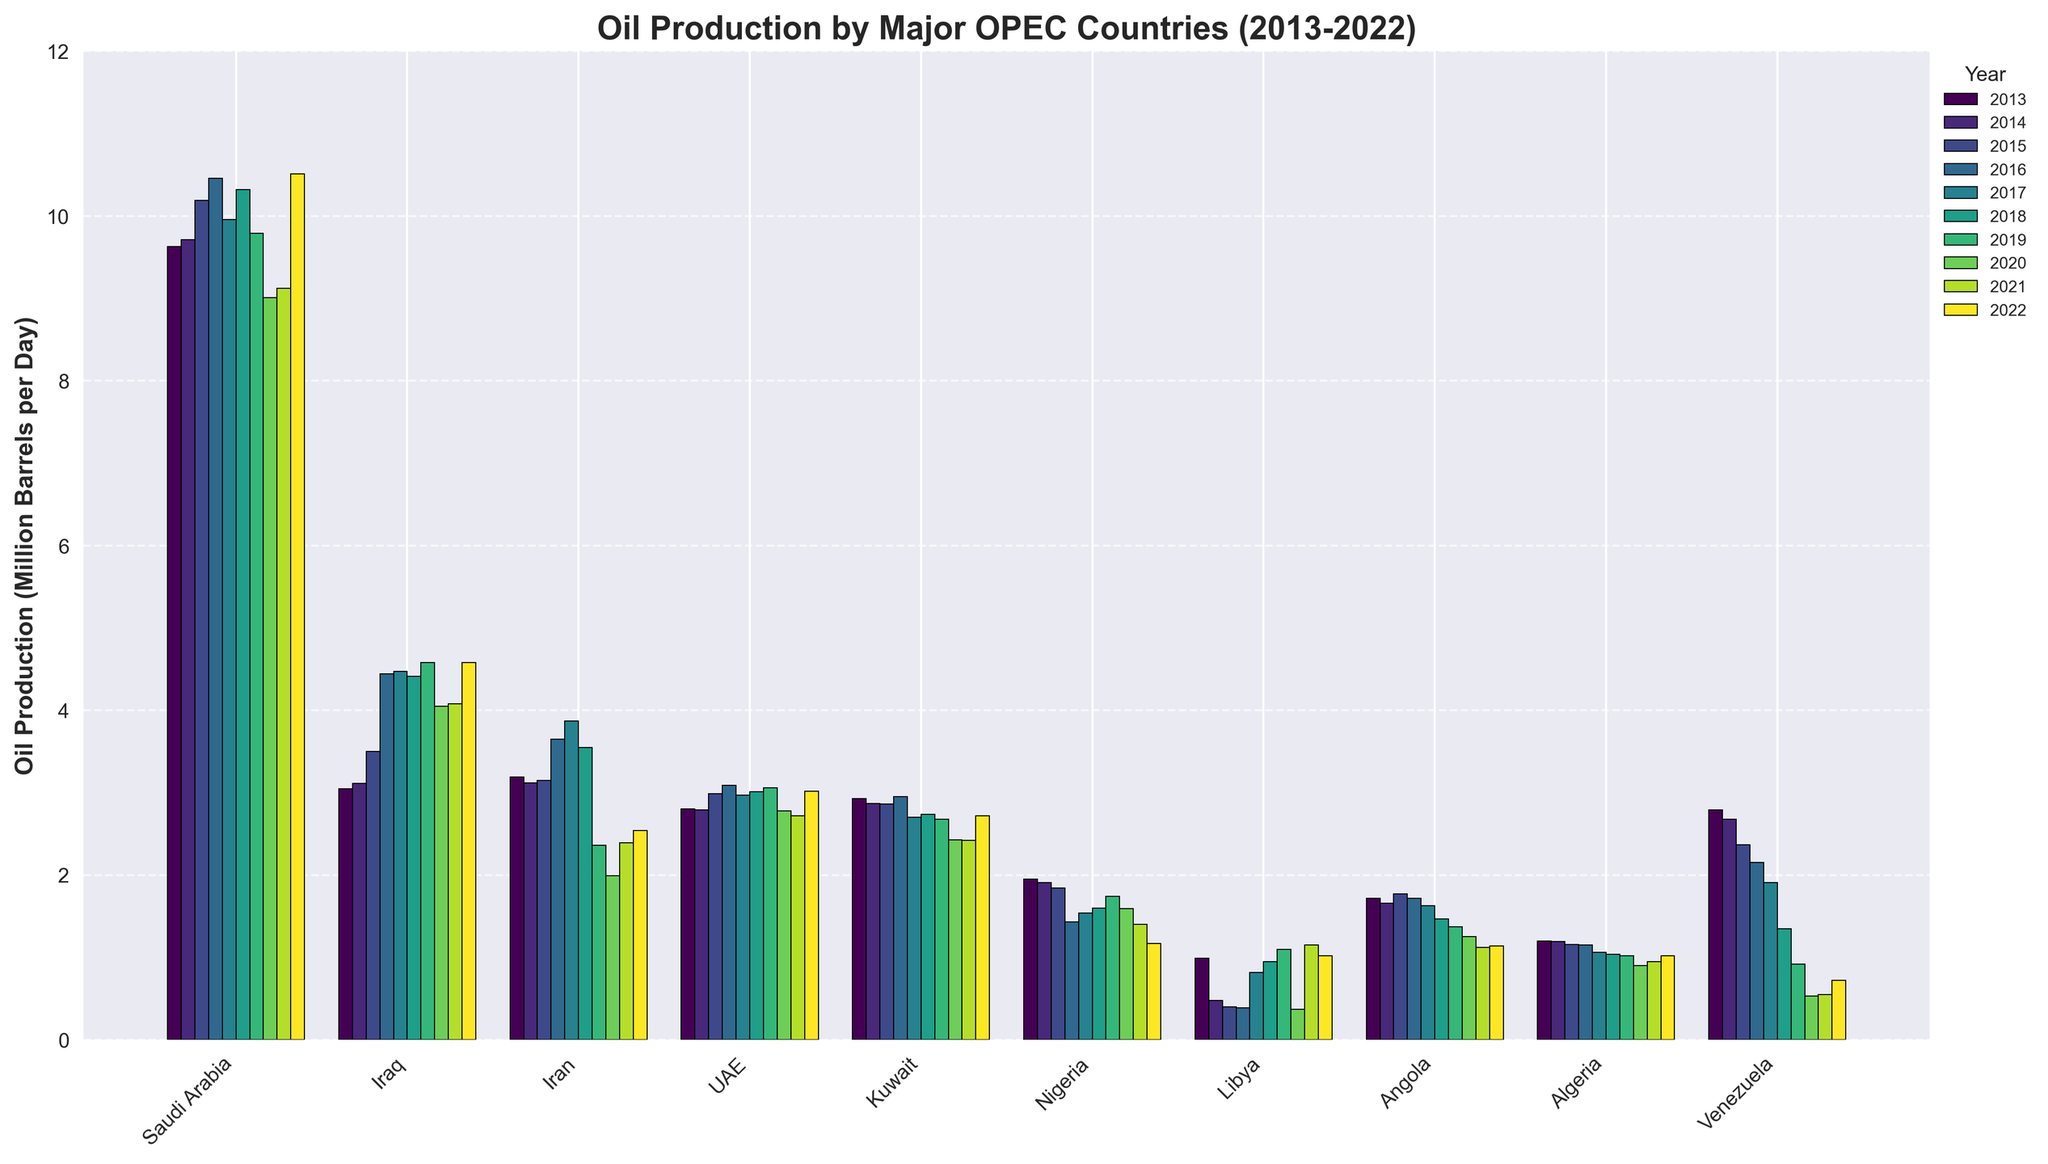What year did Saudi Arabia have the highest oil production? According to the figure, the bar corresponding to 2022 for Saudi Arabia is the tallest among all years.
Answer: 2022 Which country had the lowest oil production in 2022? Looking at the heights of the bars for 2022, Nigeria has the shortest bar, indicating it had the lowest production.
Answer: Nigeria How did Iran's oil production change from 2015 to 2020? To answer this, compare the heights of Iran's bars for 2015 and 2020. In 2015, Iran's production was higher compared to 2020 where it significantly dropped.
Answer: It decreased What was the difference in oil production between Iraq and Libya in 2019? Check the heights of the bars for Iraq and Libya for the year 2019. Subtract Libya's production from Iraq's production for 2019.
Answer: 3.48 million barrels per day Which country showed the most consistent oil production over the decade? Consistency can be inferred by looking at the bars' heights for each year and identifying which country has the least variation. UAE shows bars of relatively similar height each year.
Answer: UAE In which year did Venezuela's oil production drop below 1 million barrels per day? Look for the years where Venezuela's bars drop below the 1 million barrels mark on the y-axis. This happens starting from 2019.
Answer: 2019 What was the total oil production of Kuwait for the first three and the last three years of the decade? Add up the values for Kuwait for 2013, 2014, and 2015. Then sum up the values for 2020, 2021, and 2022. First three years: 2.93 + 2.87 + 2.86 = 8.66. Last three years: 2.43 + 2.42 + 2.72 = 7.57
Answer: 8.66 million barrels per day for the first three years and 7.57 million barrels per day for the last three years Which country had the largest increase in oil production from 2020 to 2021? Examine the heights of the bars for each country for 2020 and 2021, and calculate the difference. Libya sees a significant bar increase between these two years.
Answer: Libya Did any country experience a consistent increase in oil production every year? Observe the trends in the heights of the bars for each country year by year. No country showed a consistent increase every year throughout the decade.
Answer: No 